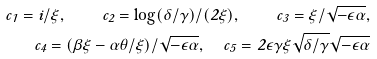Convert formula to latex. <formula><loc_0><loc_0><loc_500><loc_500>c _ { 1 } = i / \xi , \quad c _ { 2 } = \log ( \delta / \gamma ) / ( 2 \xi ) , \quad c _ { 3 } = \xi / \sqrt { - \epsilon \alpha } , \\ c _ { 4 } = ( \beta \xi - \alpha \theta / \xi ) / \sqrt { - \epsilon \alpha } , \quad c _ { 5 } = 2 \epsilon \gamma \xi \sqrt { \delta / \gamma } \sqrt { - \epsilon \alpha }</formula> 